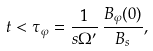<formula> <loc_0><loc_0><loc_500><loc_500>t < \tau _ { \varphi } = \frac { 1 } { s \Omega ^ { \prime } } \, \frac { B _ { \varphi } ( 0 ) } { B _ { s } } ,</formula> 